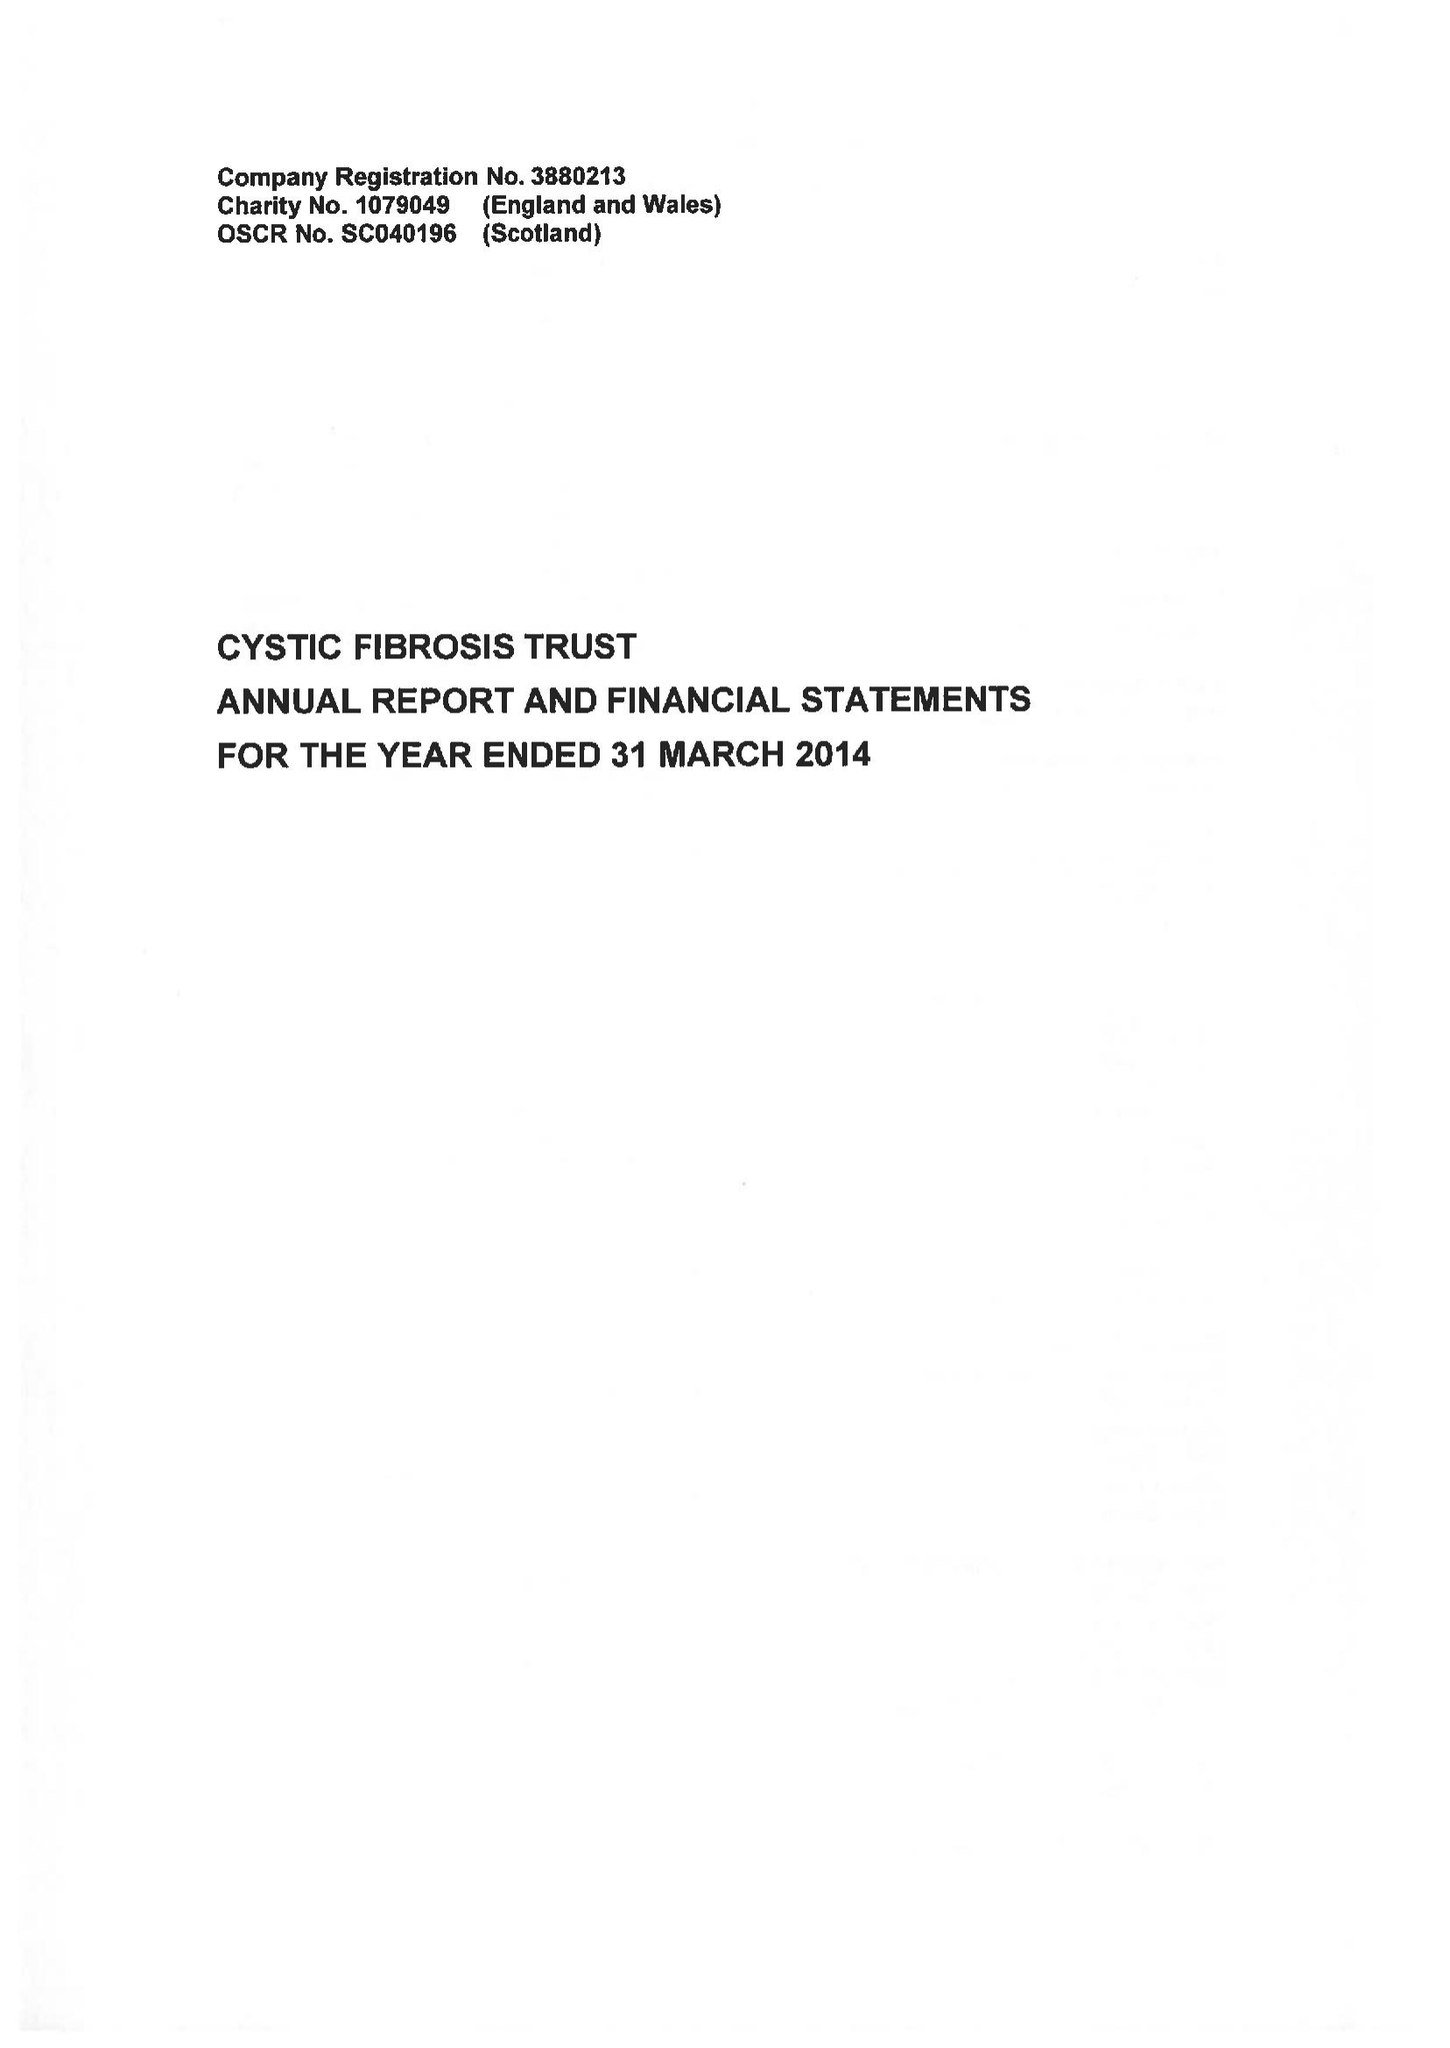What is the value for the address__postcode?
Answer the question using a single word or phrase. EC3N 1RE 